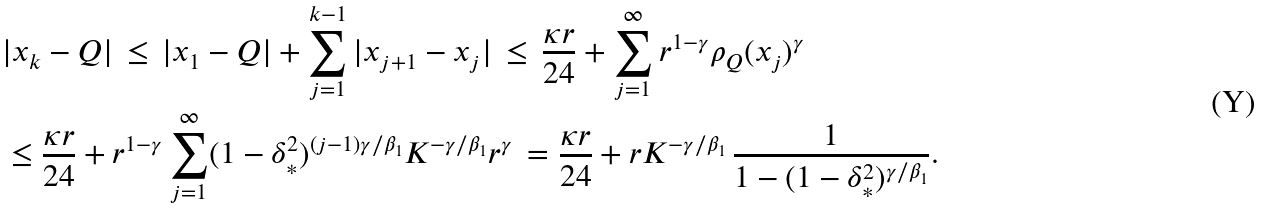<formula> <loc_0><loc_0><loc_500><loc_500>& | x _ { k } - Q | \, \leq \, | x _ { 1 } - Q | + \sum _ { j = 1 } ^ { k - 1 } | x _ { j + 1 } - x _ { j } | \, \leq \, \frac { \kappa r } { 2 4 } + \sum _ { j = 1 } ^ { \infty } r ^ { 1 - \gamma } \rho _ { Q } ( x _ { j } ) ^ { \gamma } \\ & \leq \frac { \kappa r } { 2 4 } + r ^ { 1 - \gamma } \sum _ { j = 1 } ^ { \infty } ( 1 - \delta _ { * } ^ { 2 } ) ^ { ( j - 1 ) \gamma / \beta _ { 1 } } K ^ { - \gamma / \beta _ { 1 } } r ^ { \gamma } \, = \frac { \kappa r } { 2 4 } + r K ^ { - \gamma / \beta _ { 1 } } \, \frac { 1 } { 1 - ( 1 - \delta _ { * } ^ { 2 } ) ^ { \gamma / \beta _ { 1 } } } .</formula> 